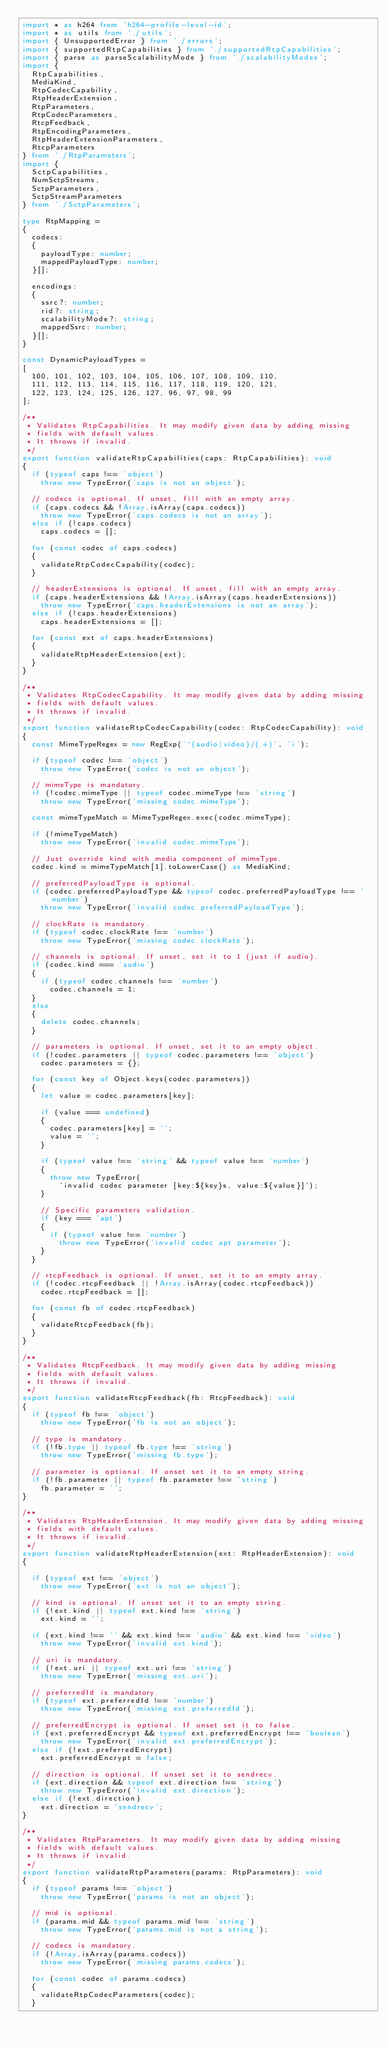Convert code to text. <code><loc_0><loc_0><loc_500><loc_500><_TypeScript_>import * as h264 from 'h264-profile-level-id';
import * as utils from './utils';
import { UnsupportedError } from './errors';
import { supportedRtpCapabilities } from './supportedRtpCapabilities';
import { parse as parseScalabilityMode } from './scalabilityModes';
import {
	RtpCapabilities,
	MediaKind,
	RtpCodecCapability,
	RtpHeaderExtension,
	RtpParameters,
	RtpCodecParameters,
	RtcpFeedback,
	RtpEncodingParameters,
	RtpHeaderExtensionParameters,
	RtcpParameters
} from './RtpParameters';
import {
	SctpCapabilities,
	NumSctpStreams,
	SctpParameters,
	SctpStreamParameters
} from './SctpParameters';

type RtpMapping =
{
	codecs:
	{
		payloadType: number;
		mappedPayloadType: number;
	}[];

	encodings:
	{
		ssrc?: number;
		rid?: string;
		scalabilityMode?: string;
		mappedSsrc: number;
	}[];
}

const DynamicPayloadTypes =
[
	100, 101, 102, 103, 104, 105, 106, 107, 108, 109, 110,
	111, 112, 113, 114, 115, 116, 117, 118, 119, 120, 121,
	122, 123, 124, 125, 126, 127, 96, 97, 98, 99
];

/**
 * Validates RtpCapabilities. It may modify given data by adding missing
 * fields with default values.
 * It throws if invalid.
 */
export function validateRtpCapabilities(caps: RtpCapabilities): void
{
	if (typeof caps !== 'object')
		throw new TypeError('caps is not an object');

	// codecs is optional. If unset, fill with an empty array.
	if (caps.codecs && !Array.isArray(caps.codecs))
		throw new TypeError('caps.codecs is not an array');
	else if (!caps.codecs)
		caps.codecs = [];

	for (const codec of caps.codecs)
	{
		validateRtpCodecCapability(codec);
	}

	// headerExtensions is optional. If unset, fill with an empty array.
	if (caps.headerExtensions && !Array.isArray(caps.headerExtensions))
		throw new TypeError('caps.headerExtensions is not an array');
	else if (!caps.headerExtensions)
		caps.headerExtensions = [];

	for (const ext of caps.headerExtensions)
	{
		validateRtpHeaderExtension(ext);
	}
}

/**
 * Validates RtpCodecCapability. It may modify given data by adding missing
 * fields with default values.
 * It throws if invalid.
 */
export function validateRtpCodecCapability(codec: RtpCodecCapability): void
{
	const MimeTypeRegex = new RegExp('^(audio|video)/(.+)', 'i');

	if (typeof codec !== 'object')
		throw new TypeError('codec is not an object');

	// mimeType is mandatory.
	if (!codec.mimeType || typeof codec.mimeType !== 'string')
		throw new TypeError('missing codec.mimeType');

	const mimeTypeMatch = MimeTypeRegex.exec(codec.mimeType);

	if (!mimeTypeMatch)
		throw new TypeError('invalid codec.mimeType');

	// Just override kind with media component of mimeType.
	codec.kind = mimeTypeMatch[1].toLowerCase() as MediaKind;

	// preferredPayloadType is optional.
	if (codec.preferredPayloadType && typeof codec.preferredPayloadType !== 'number')
		throw new TypeError('invalid codec.preferredPayloadType');

	// clockRate is mandatory.
	if (typeof codec.clockRate !== 'number')
		throw new TypeError('missing codec.clockRate');

	// channels is optional. If unset, set it to 1 (just if audio).
	if (codec.kind === 'audio')
	{
		if (typeof codec.channels !== 'number')
			codec.channels = 1;
	}
	else
	{
		delete codec.channels;
	}

	// parameters is optional. If unset, set it to an empty object.
	if (!codec.parameters || typeof codec.parameters !== 'object')
		codec.parameters = {};

	for (const key of Object.keys(codec.parameters))
	{
		let value = codec.parameters[key];

		if (value === undefined)
		{
			codec.parameters[key] = '';
			value = '';
		}

		if (typeof value !== 'string' && typeof value !== 'number')
		{
			throw new TypeError(
				`invalid codec parameter [key:${key}s, value:${value}]`);
		}

		// Specific parameters validation.
		if (key === 'apt')
		{
			if (typeof value !== 'number')
				throw new TypeError('invalid codec apt parameter');
		}
	}

	// rtcpFeedback is optional. If unset, set it to an empty array.
	if (!codec.rtcpFeedback || !Array.isArray(codec.rtcpFeedback))
		codec.rtcpFeedback = [];

	for (const fb of codec.rtcpFeedback)
	{
		validateRtcpFeedback(fb);
	}
}

/**
 * Validates RtcpFeedback. It may modify given data by adding missing
 * fields with default values.
 * It throws if invalid.
 */
export function validateRtcpFeedback(fb: RtcpFeedback): void
{
	if (typeof fb !== 'object')
		throw new TypeError('fb is not an object');

	// type is mandatory.
	if (!fb.type || typeof fb.type !== 'string')
		throw new TypeError('missing fb.type');

	// parameter is optional. If unset set it to an empty string.
	if (!fb.parameter || typeof fb.parameter !== 'string')
		fb.parameter = '';
}

/**
 * Validates RtpHeaderExtension. It may modify given data by adding missing
 * fields with default values.
 * It throws if invalid.
 */
export function validateRtpHeaderExtension(ext: RtpHeaderExtension): void
{

	if (typeof ext !== 'object')
		throw new TypeError('ext is not an object');

	// kind is optional. If unset set it to an empty string.
	if (!ext.kind || typeof ext.kind !== 'string')
		ext.kind = '';

	if (ext.kind !== '' && ext.kind !== 'audio' && ext.kind !== 'video')
		throw new TypeError('invalid ext.kind');

	// uri is mandatory.
	if (!ext.uri || typeof ext.uri !== 'string')
		throw new TypeError('missing ext.uri');

	// preferredId is mandatory.
	if (typeof ext.preferredId !== 'number')
		throw new TypeError('missing ext.preferredId');

	// preferredEncrypt is optional. If unset set it to false.
	if (ext.preferredEncrypt && typeof ext.preferredEncrypt !== 'boolean')
		throw new TypeError('invalid ext.preferredEncrypt');
	else if (!ext.preferredEncrypt)
		ext.preferredEncrypt = false;

	// direction is optional. If unset set it to sendrecv.
	if (ext.direction && typeof ext.direction !== 'string')
		throw new TypeError('invalid ext.direction');
	else if (!ext.direction)
		ext.direction = 'sendrecv';
}

/**
 * Validates RtpParameters. It may modify given data by adding missing
 * fields with default values.
 * It throws if invalid.
 */
export function validateRtpParameters(params: RtpParameters): void
{
	if (typeof params !== 'object')
		throw new TypeError('params is not an object');

	// mid is optional.
	if (params.mid && typeof params.mid !== 'string')
		throw new TypeError('params.mid is not a string');

	// codecs is mandatory.
	if (!Array.isArray(params.codecs))
		throw new TypeError('missing params.codecs');

	for (const codec of params.codecs)
	{
		validateRtpCodecParameters(codec);
	}
</code> 